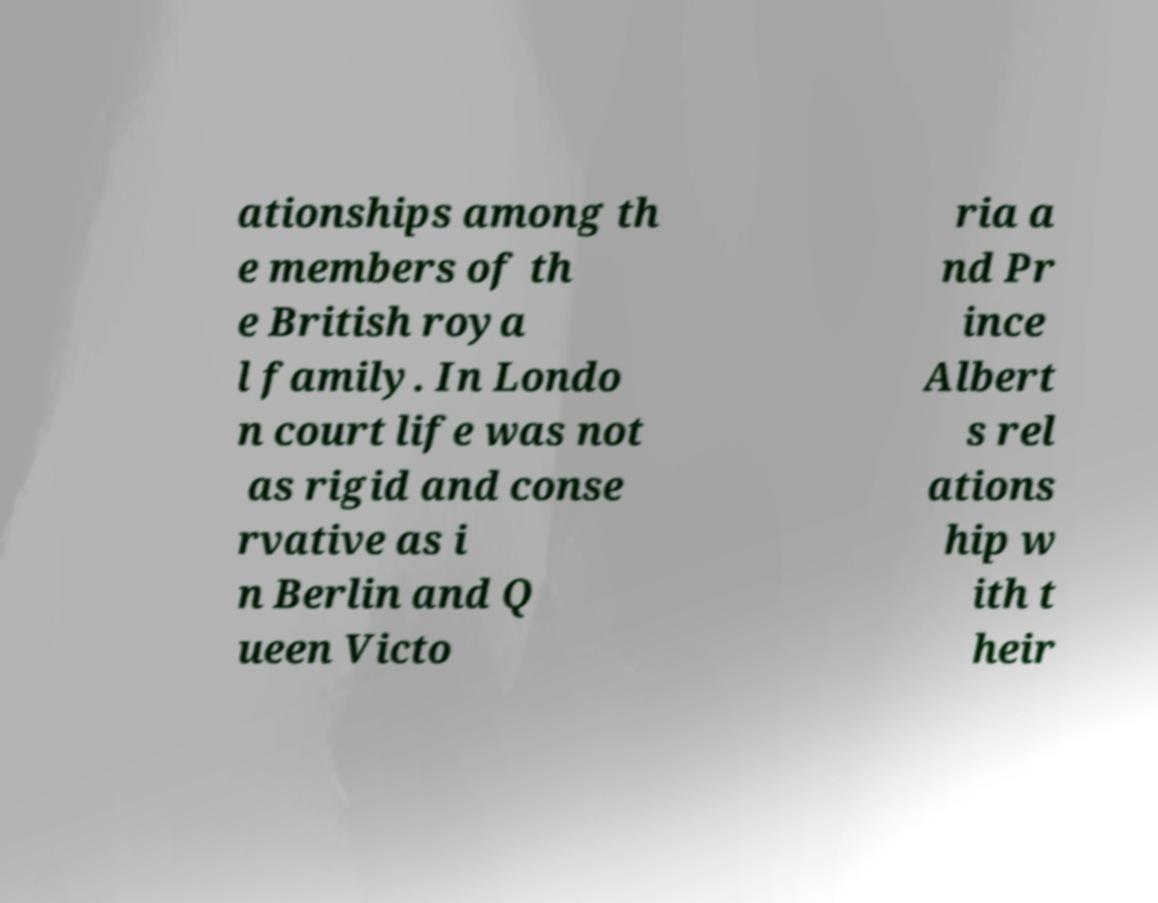Could you assist in decoding the text presented in this image and type it out clearly? ationships among th e members of th e British roya l family. In Londo n court life was not as rigid and conse rvative as i n Berlin and Q ueen Victo ria a nd Pr ince Albert s rel ations hip w ith t heir 